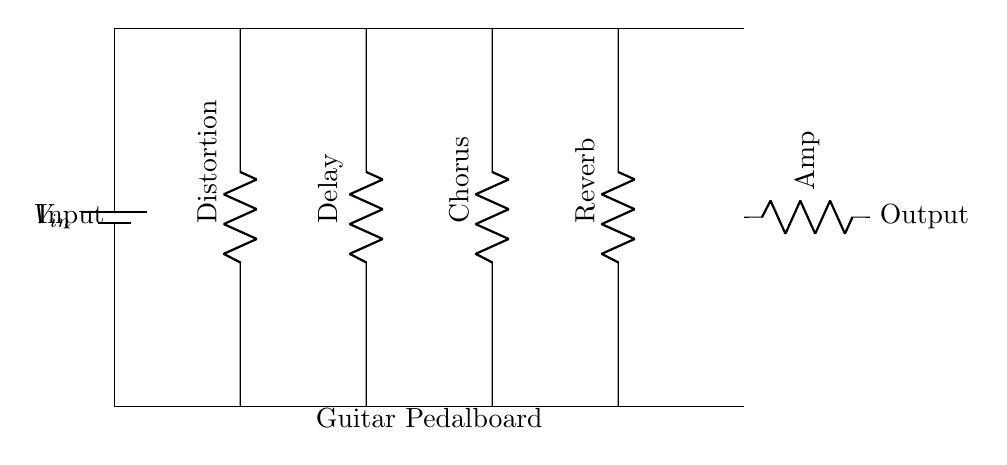What components are in this circuit? The circuit diagram has four pedals: Distortion, Delay, Chorus, and Reverb, all connected in parallel to the main line.
Answer: Distortion, Delay, Chorus, Reverb What is the function of the output labeled "Amp"? The output labeled "Amp" indicates that the signal from the pedals is sent to an amplifier for sound amplification and processing.
Answer: Amplifier How many pedals are connected in parallel? The circuit shows four pedals connected in parallel, each receiving the same input voltage.
Answer: Four What is the significance of the vertical orientation of the pedals? The vertical orientation symbolizes that the components are arranged to show that they are connected to the same voltage source and that their connections are on the main power line.
Answer: Connection orientation What is the input voltage for the pedalboard? The voltage source labeled as V_in supplies the input voltage for the entire pedalboard system, ensuring each effect pedal receives power.
Answer: V_in What would happen if one pedal fails in this setup? If one pedal fails, the other pedals would continue to function normally because they are wired in parallel, allowing for independent operation.
Answer: Independent operation How does this circuit type affect the output signal? In a parallel circuit, each effect pedal contributes to the overall signal independently, allowing for multiple effects to be used simultaneously without affecting each other's performance.
Answer: Simultaneous effects 